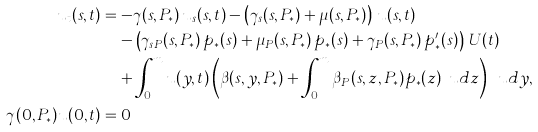<formula> <loc_0><loc_0><loc_500><loc_500>u _ { t } ( s , t ) & = - \gamma ( s , P _ { * } ) \, u _ { s } ( s , t ) - \left ( \gamma _ { s } ( s , P _ { * } ) + \mu ( s , P _ { * } ) \right ) \, u ( s , t ) \\ & \quad - \left ( \gamma _ { s P } ( s , P _ { * } ) \, p _ { * } ( s ) + \mu _ { P } ( s , P _ { * } ) \, p _ { * } ( s ) + \gamma _ { P } ( s , P _ { * } ) \, p _ { * } ^ { \prime } ( s ) \right ) \, U ( t ) \\ & \quad + \int _ { 0 } ^ { m } u ( y , t ) \left ( \beta ( s , y , P _ { * } ) + \int _ { 0 } ^ { m } \beta _ { P } ( s , z , P _ { * } ) p _ { * } ( z ) \, \ u d z \right ) \, \ u d y , \\ \gamma ( 0 , P _ { * } ) u ( 0 , t ) & = 0</formula> 